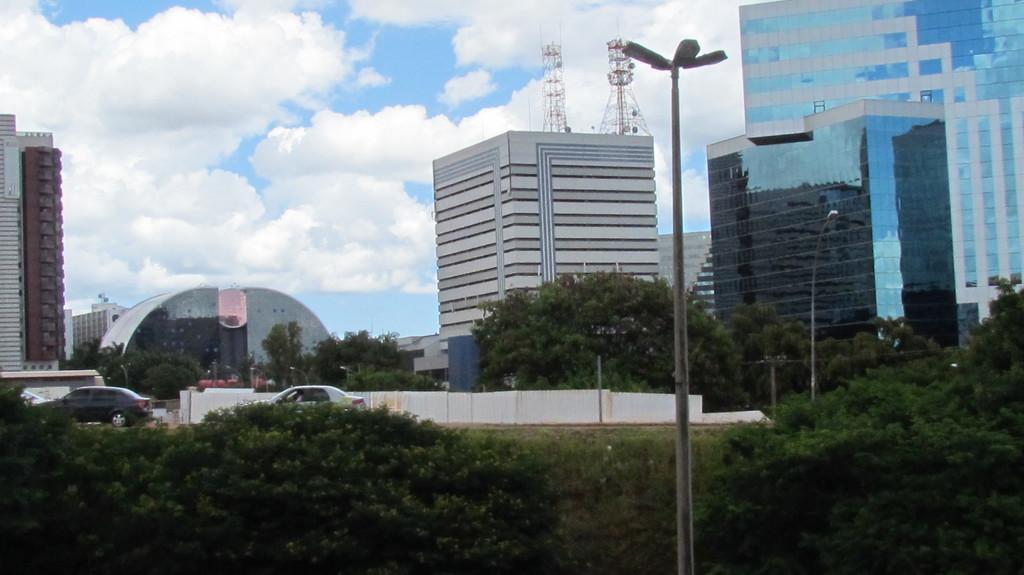In one or two sentences, can you explain what this image depicts? In this image we can see a few buildings, there are some vehicles, poles, lights, trees and towers, also we can see the wall, in the background, we can see the sky with clouds. 